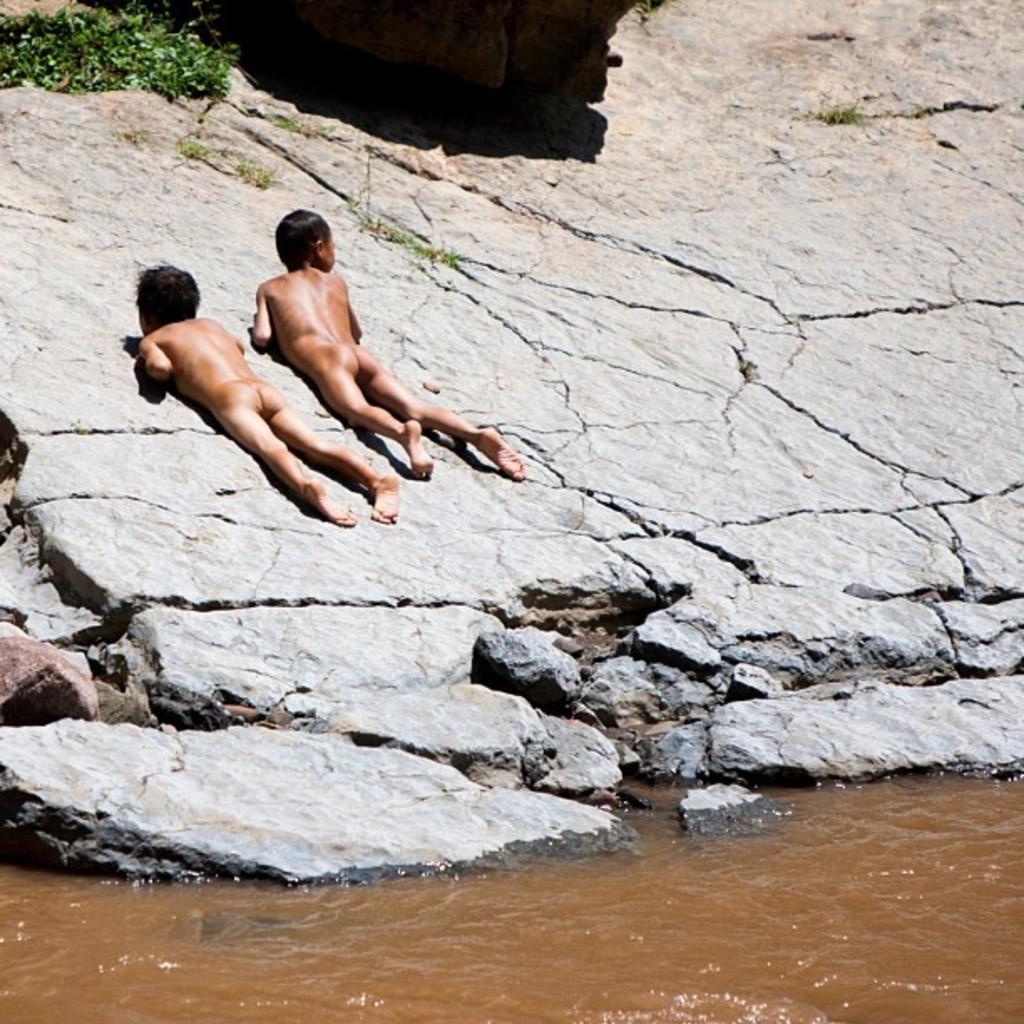Could you give a brief overview of what you see in this image? In this picture there is water at the bottom side of the image and there are children those who are lying on the rock and there is greenery in the top left side of the image. 